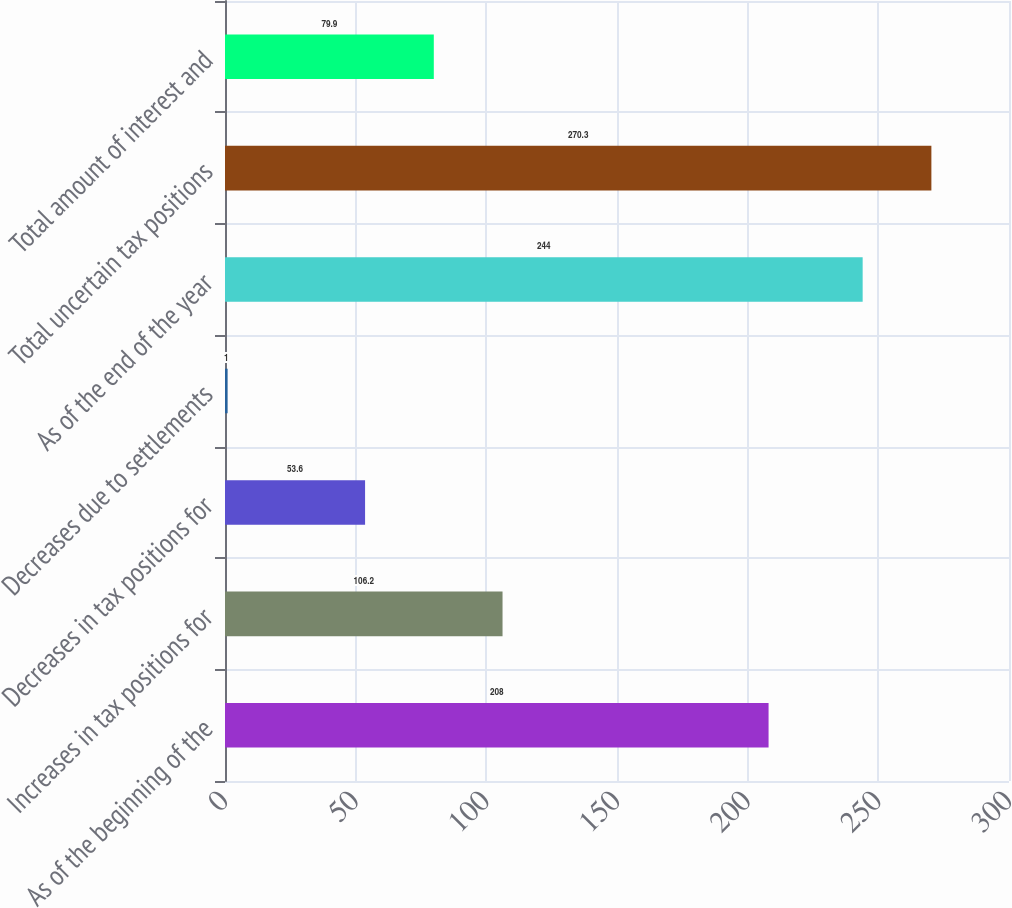Convert chart. <chart><loc_0><loc_0><loc_500><loc_500><bar_chart><fcel>As of the beginning of the<fcel>Increases in tax positions for<fcel>Decreases in tax positions for<fcel>Decreases due to settlements<fcel>As of the end of the year<fcel>Total uncertain tax positions<fcel>Total amount of interest and<nl><fcel>208<fcel>106.2<fcel>53.6<fcel>1<fcel>244<fcel>270.3<fcel>79.9<nl></chart> 